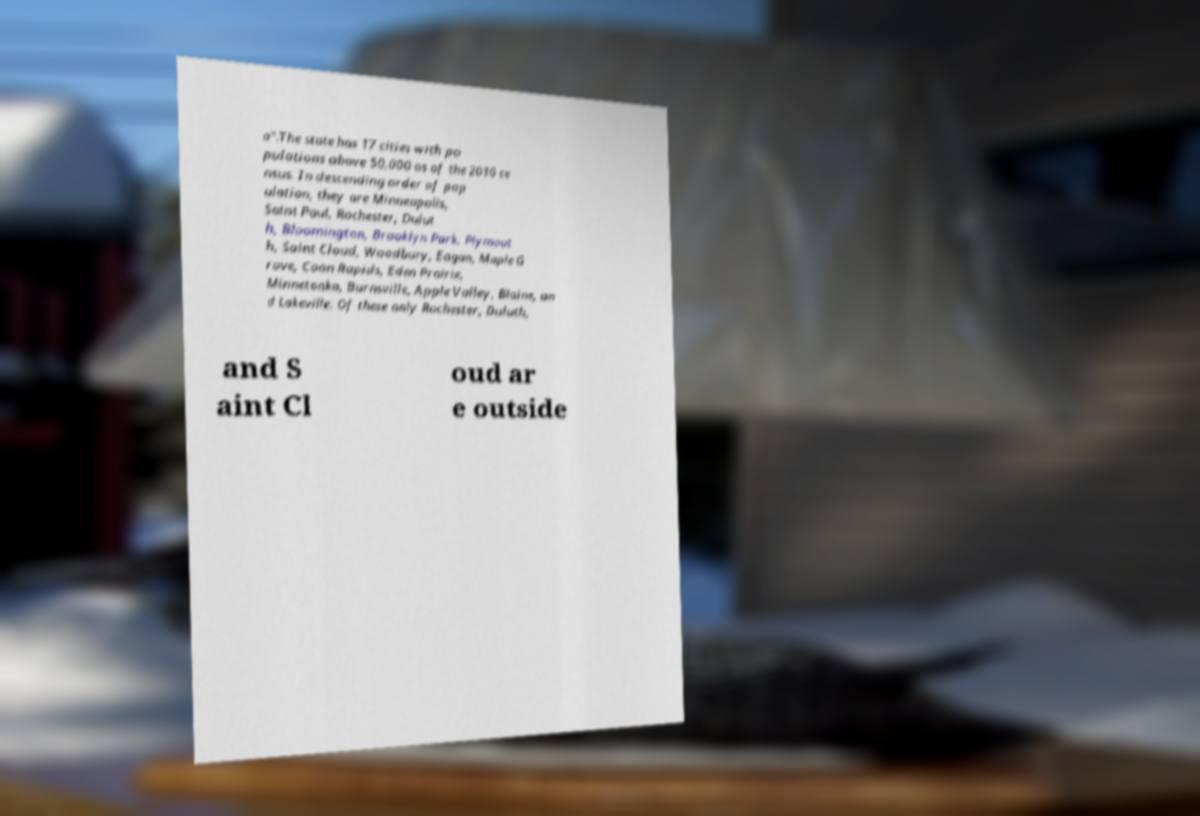Could you extract and type out the text from this image? a".The state has 17 cities with po pulations above 50,000 as of the 2010 ce nsus. In descending order of pop ulation, they are Minneapolis, Saint Paul, Rochester, Dulut h, Bloomington, Brooklyn Park, Plymout h, Saint Cloud, Woodbury, Eagan, Maple G rove, Coon Rapids, Eden Prairie, Minnetonka, Burnsville, Apple Valley, Blaine, an d Lakeville. Of these only Rochester, Duluth, and S aint Cl oud ar e outside 